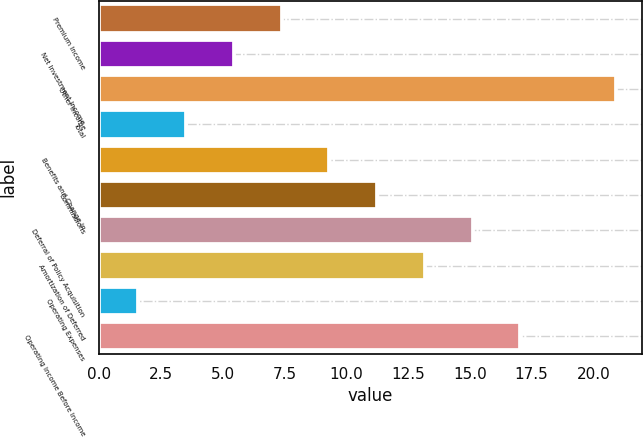<chart> <loc_0><loc_0><loc_500><loc_500><bar_chart><fcel>Premium Income<fcel>Net Investment Income<fcel>Other Income<fcel>Total<fcel>Benefits and Change in<fcel>Commissions<fcel>Deferral of Policy Acquisition<fcel>Amortization of Deferred<fcel>Operating Expenses<fcel>Operating Income Before Income<nl><fcel>7.39<fcel>5.46<fcel>20.9<fcel>3.53<fcel>9.32<fcel>11.25<fcel>15.11<fcel>13.18<fcel>1.6<fcel>17.04<nl></chart> 